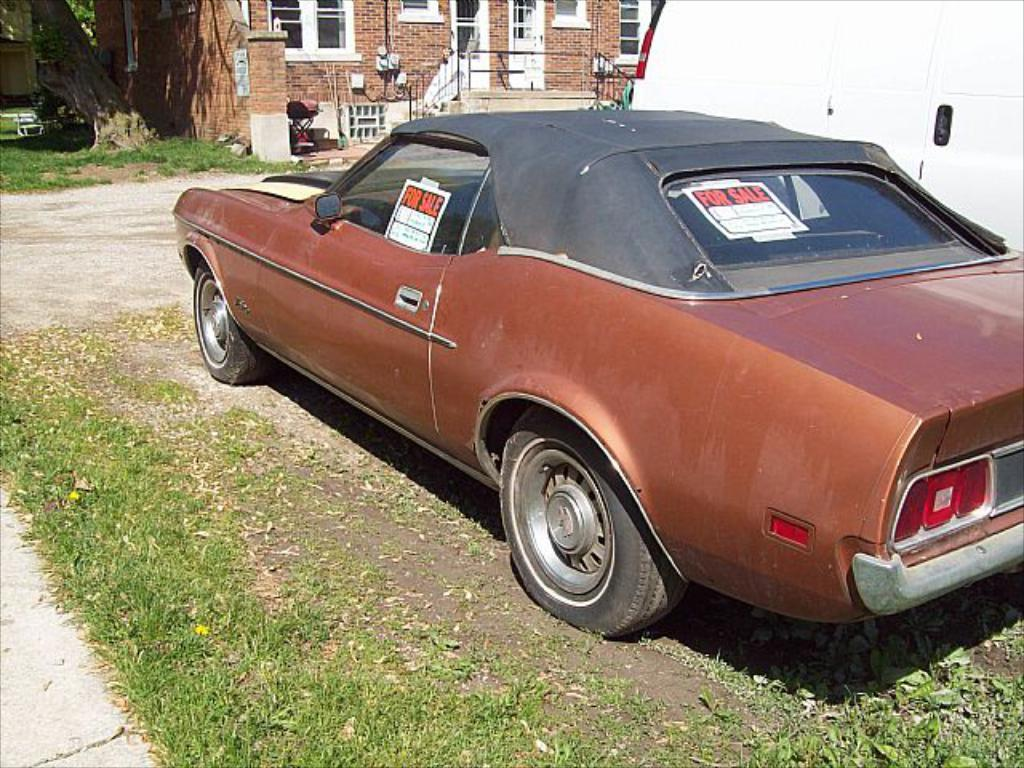What type of structures can be seen in the image? There are buildings in the image. Can you describe the location of the car in the image? The car is parked beside a wall in the image. What type of shop can be seen in the image? There is no shop visible in the image; it only features buildings and a parked car. Is it raining in the image? There is no indication of rain in the image. 